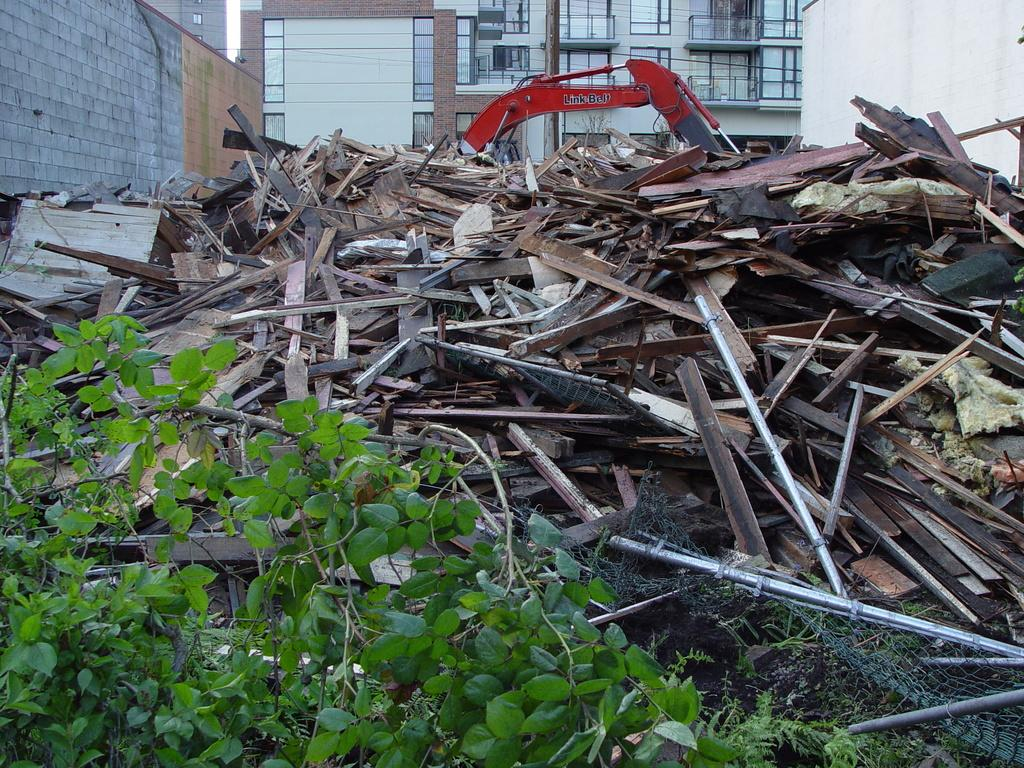What type of structure is shown in the image? There is a building with windows in the image. What material can be seen in the image? Wooden sticks are visible in the image. What mode of transportation is present in the image? A vehicle is present in the image. What type of barrier is shown in the image? There is a mesh in the image. What vertical object is visible in the image? A pole is visible in the image. What type of living organism is present in the image? A plant is present in the image. What action is the boat performing in the image? There is no boat present in the image, so no action can be observed. 